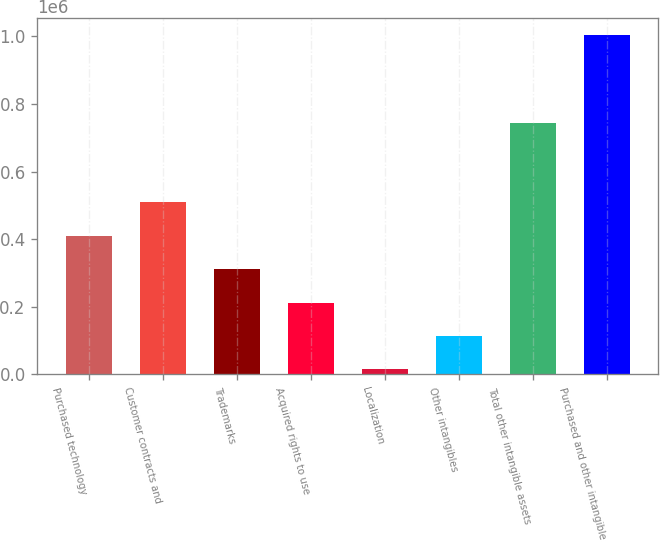Convert chart. <chart><loc_0><loc_0><loc_500><loc_500><bar_chart><fcel>Purchased technology<fcel>Customer contracts and<fcel>Trademarks<fcel>Acquired rights to use<fcel>Localization<fcel>Other intangibles<fcel>Total other intangible assets<fcel>Purchased and other intangible<nl><fcel>410290<fcel>509170<fcel>311410<fcel>212529<fcel>14768<fcel>113648<fcel>743375<fcel>1.00357e+06<nl></chart> 